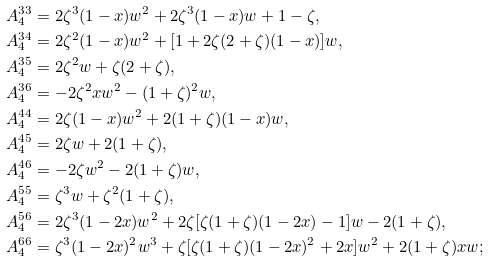<formula> <loc_0><loc_0><loc_500><loc_500>A ^ { 3 3 } _ { 4 } & = 2 \zeta ^ { 3 } ( 1 - x ) w ^ { 2 } + 2 \zeta ^ { 3 } ( 1 - x ) w + 1 - \zeta , \\ A ^ { 3 4 } _ { 4 } & = 2 \zeta ^ { 2 } ( 1 - x ) w ^ { 2 } + [ 1 + 2 \zeta ( 2 + \zeta ) ( 1 - x ) ] w , \\ A ^ { 3 5 } _ { 4 } & = 2 \zeta ^ { 2 } w + \zeta ( 2 + \zeta ) , \\ A ^ { 3 6 } _ { 4 } & = - 2 \zeta ^ { 2 } x w ^ { 2 } - ( 1 + \zeta ) ^ { 2 } w , \\ A ^ { 4 4 } _ { 4 } & = 2 \zeta ( 1 - x ) w ^ { 2 } + 2 ( 1 + \zeta ) ( 1 - x ) w , \\ A ^ { 4 5 } _ { 4 } & = 2 \zeta w + 2 ( 1 + \zeta ) , \\ A ^ { 4 6 } _ { 4 } & = - 2 \zeta w ^ { 2 } - 2 ( 1 + \zeta ) w , \\ A ^ { 5 5 } _ { 4 } & = \zeta ^ { 3 } w + \zeta ^ { 2 } ( 1 + \zeta ) , \\ A ^ { 5 6 } _ { 4 } & = 2 \zeta ^ { 3 } ( 1 - 2 x ) w ^ { 2 } + 2 \zeta [ \zeta ( 1 + \zeta ) ( 1 - 2 x ) - 1 ] w - 2 ( 1 + \zeta ) , \\ A ^ { 6 6 } _ { 4 } & = \zeta ^ { 3 } ( 1 - 2 x ) ^ { 2 } w ^ { 3 } + \zeta [ \zeta ( 1 + \zeta ) ( 1 - 2 x ) ^ { 2 } + 2 x ] w ^ { 2 } + 2 ( 1 + \zeta ) x w ;</formula> 